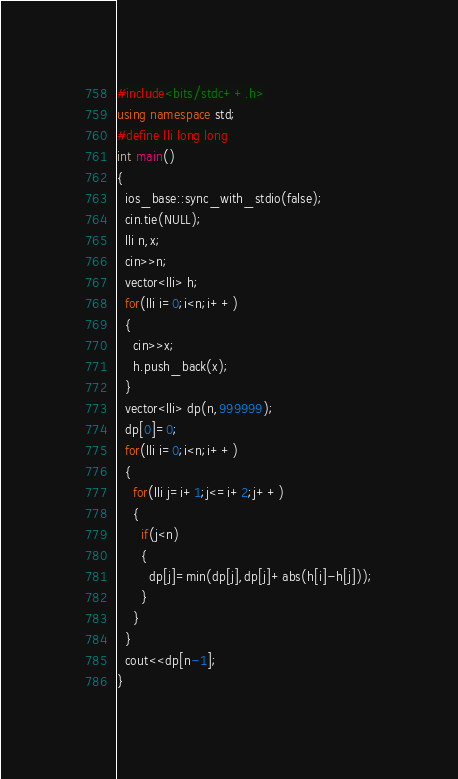<code> <loc_0><loc_0><loc_500><loc_500><_C++_>#include<bits/stdc++.h>
using namespace std;
#define lli long long
int main()
{
  ios_base::sync_with_stdio(false);
  cin.tie(NULL);
  lli n,x;
  cin>>n;
  vector<lli> h;
  for(lli i=0;i<n;i++)
  {
    cin>>x;
    h.push_back(x);
  }
  vector<lli> dp(n,999999);
  dp[0]=0;
  for(lli i=0;i<n;i++)
  {
    for(lli j=i+1;j<=i+2;j++)
    {
      if(j<n)
      {
      	dp[j]=min(dp[j],dp[j]+abs(h[i]-h[j]));
      }
    }
  }
  cout<<dp[n-1];
}</code> 